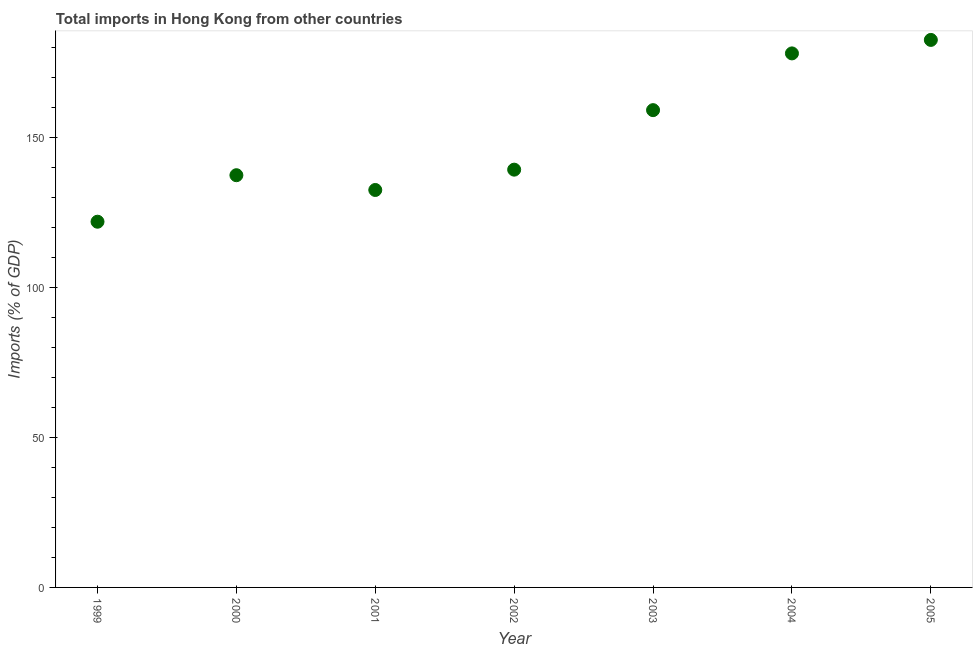What is the total imports in 2000?
Your response must be concise. 137.36. Across all years, what is the maximum total imports?
Your answer should be compact. 182.44. Across all years, what is the minimum total imports?
Keep it short and to the point. 121.86. In which year was the total imports maximum?
Make the answer very short. 2005. In which year was the total imports minimum?
Your answer should be compact. 1999. What is the sum of the total imports?
Make the answer very short. 1050.26. What is the difference between the total imports in 2000 and 2003?
Make the answer very short. -21.68. What is the average total imports per year?
Your response must be concise. 150.04. What is the median total imports?
Your answer should be compact. 139.21. In how many years, is the total imports greater than 70 %?
Keep it short and to the point. 7. What is the ratio of the total imports in 1999 to that in 2004?
Ensure brevity in your answer.  0.68. Is the total imports in 2001 less than that in 2003?
Make the answer very short. Yes. What is the difference between the highest and the second highest total imports?
Ensure brevity in your answer.  4.49. What is the difference between the highest and the lowest total imports?
Provide a succinct answer. 60.58. How many years are there in the graph?
Provide a succinct answer. 7. What is the difference between two consecutive major ticks on the Y-axis?
Offer a very short reply. 50. Are the values on the major ticks of Y-axis written in scientific E-notation?
Offer a very short reply. No. What is the title of the graph?
Ensure brevity in your answer.  Total imports in Hong Kong from other countries. What is the label or title of the X-axis?
Give a very brief answer. Year. What is the label or title of the Y-axis?
Offer a terse response. Imports (% of GDP). What is the Imports (% of GDP) in 1999?
Give a very brief answer. 121.86. What is the Imports (% of GDP) in 2000?
Ensure brevity in your answer.  137.36. What is the Imports (% of GDP) in 2001?
Offer a terse response. 132.43. What is the Imports (% of GDP) in 2002?
Make the answer very short. 139.21. What is the Imports (% of GDP) in 2003?
Your answer should be very brief. 159.03. What is the Imports (% of GDP) in 2004?
Your response must be concise. 177.94. What is the Imports (% of GDP) in 2005?
Ensure brevity in your answer.  182.44. What is the difference between the Imports (% of GDP) in 1999 and 2000?
Give a very brief answer. -15.5. What is the difference between the Imports (% of GDP) in 1999 and 2001?
Provide a short and direct response. -10.57. What is the difference between the Imports (% of GDP) in 1999 and 2002?
Offer a very short reply. -17.35. What is the difference between the Imports (% of GDP) in 1999 and 2003?
Provide a succinct answer. -37.18. What is the difference between the Imports (% of GDP) in 1999 and 2004?
Ensure brevity in your answer.  -56.08. What is the difference between the Imports (% of GDP) in 1999 and 2005?
Your answer should be compact. -60.58. What is the difference between the Imports (% of GDP) in 2000 and 2001?
Ensure brevity in your answer.  4.92. What is the difference between the Imports (% of GDP) in 2000 and 2002?
Make the answer very short. -1.85. What is the difference between the Imports (% of GDP) in 2000 and 2003?
Offer a very short reply. -21.68. What is the difference between the Imports (% of GDP) in 2000 and 2004?
Make the answer very short. -40.59. What is the difference between the Imports (% of GDP) in 2000 and 2005?
Offer a very short reply. -45.08. What is the difference between the Imports (% of GDP) in 2001 and 2002?
Offer a terse response. -6.77. What is the difference between the Imports (% of GDP) in 2001 and 2003?
Ensure brevity in your answer.  -26.6. What is the difference between the Imports (% of GDP) in 2001 and 2004?
Make the answer very short. -45.51. What is the difference between the Imports (% of GDP) in 2001 and 2005?
Keep it short and to the point. -50. What is the difference between the Imports (% of GDP) in 2002 and 2003?
Give a very brief answer. -19.83. What is the difference between the Imports (% of GDP) in 2002 and 2004?
Give a very brief answer. -38.74. What is the difference between the Imports (% of GDP) in 2002 and 2005?
Offer a terse response. -43.23. What is the difference between the Imports (% of GDP) in 2003 and 2004?
Provide a succinct answer. -18.91. What is the difference between the Imports (% of GDP) in 2003 and 2005?
Give a very brief answer. -23.4. What is the difference between the Imports (% of GDP) in 2004 and 2005?
Your response must be concise. -4.49. What is the ratio of the Imports (% of GDP) in 1999 to that in 2000?
Offer a very short reply. 0.89. What is the ratio of the Imports (% of GDP) in 1999 to that in 2003?
Keep it short and to the point. 0.77. What is the ratio of the Imports (% of GDP) in 1999 to that in 2004?
Offer a terse response. 0.69. What is the ratio of the Imports (% of GDP) in 1999 to that in 2005?
Give a very brief answer. 0.67. What is the ratio of the Imports (% of GDP) in 2000 to that in 2001?
Provide a short and direct response. 1.04. What is the ratio of the Imports (% of GDP) in 2000 to that in 2002?
Make the answer very short. 0.99. What is the ratio of the Imports (% of GDP) in 2000 to that in 2003?
Provide a succinct answer. 0.86. What is the ratio of the Imports (% of GDP) in 2000 to that in 2004?
Make the answer very short. 0.77. What is the ratio of the Imports (% of GDP) in 2000 to that in 2005?
Your response must be concise. 0.75. What is the ratio of the Imports (% of GDP) in 2001 to that in 2002?
Make the answer very short. 0.95. What is the ratio of the Imports (% of GDP) in 2001 to that in 2003?
Ensure brevity in your answer.  0.83. What is the ratio of the Imports (% of GDP) in 2001 to that in 2004?
Provide a succinct answer. 0.74. What is the ratio of the Imports (% of GDP) in 2001 to that in 2005?
Keep it short and to the point. 0.73. What is the ratio of the Imports (% of GDP) in 2002 to that in 2004?
Make the answer very short. 0.78. What is the ratio of the Imports (% of GDP) in 2002 to that in 2005?
Your answer should be very brief. 0.76. What is the ratio of the Imports (% of GDP) in 2003 to that in 2004?
Provide a short and direct response. 0.89. What is the ratio of the Imports (% of GDP) in 2003 to that in 2005?
Offer a very short reply. 0.87. What is the ratio of the Imports (% of GDP) in 2004 to that in 2005?
Make the answer very short. 0.97. 